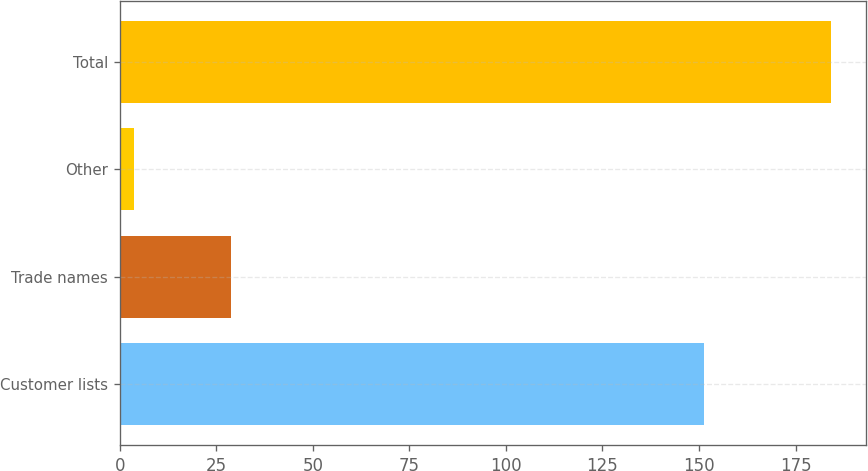Convert chart. <chart><loc_0><loc_0><loc_500><loc_500><bar_chart><fcel>Customer lists<fcel>Trade names<fcel>Other<fcel>Total<nl><fcel>151.4<fcel>28.9<fcel>3.8<fcel>184.1<nl></chart> 